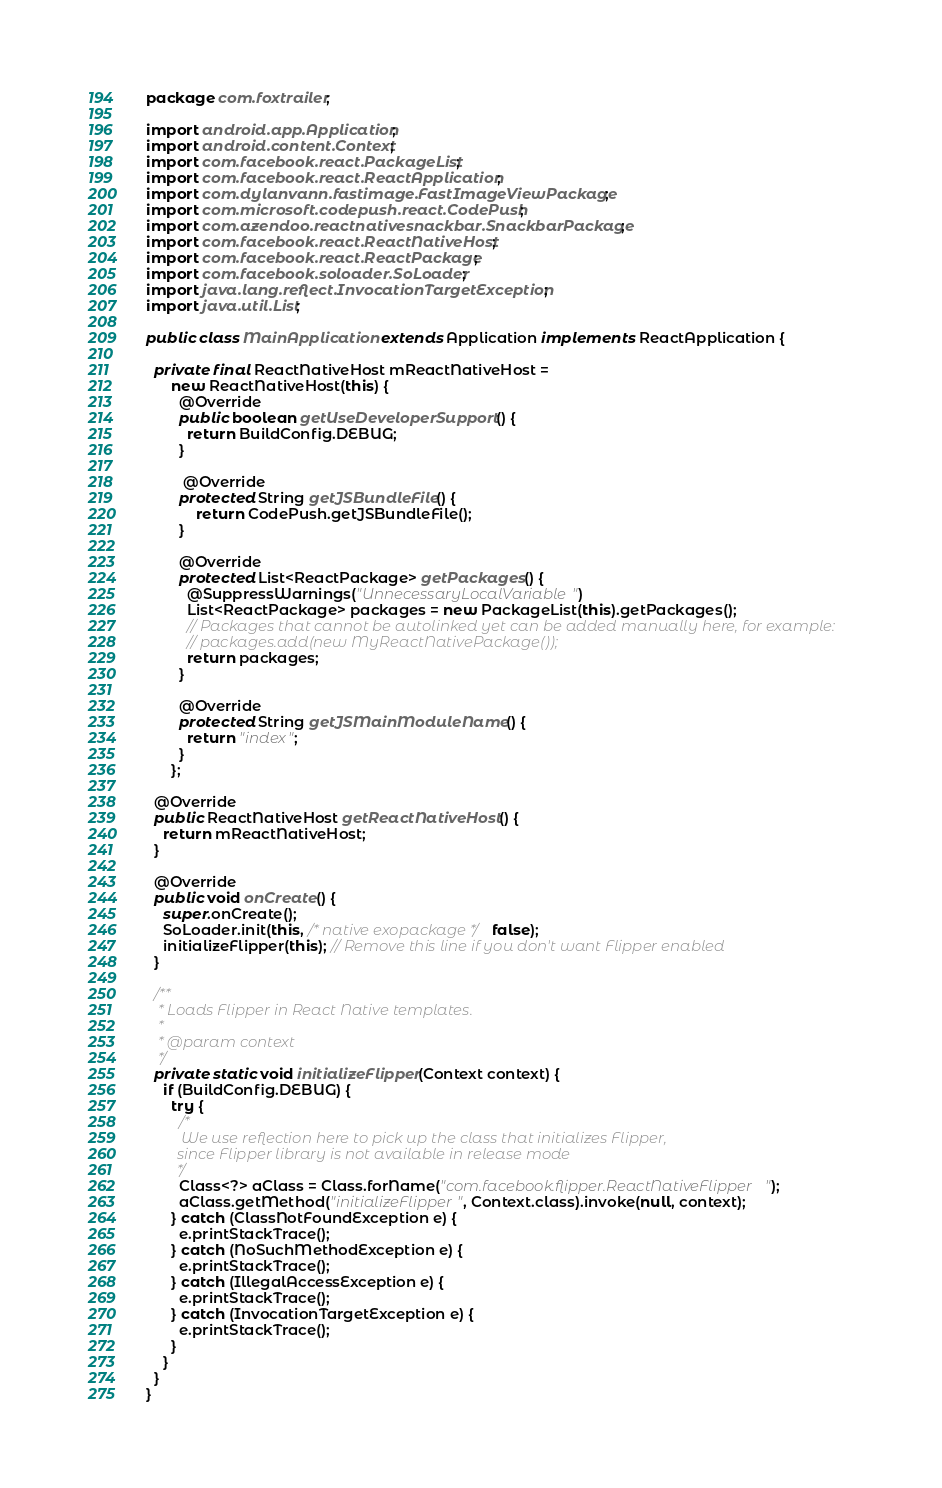<code> <loc_0><loc_0><loc_500><loc_500><_Java_>package com.foxtrailer;

import android.app.Application;
import android.content.Context;
import com.facebook.react.PackageList;
import com.facebook.react.ReactApplication;
import com.dylanvann.fastimage.FastImageViewPackage;
import com.microsoft.codepush.react.CodePush;
import com.azendoo.reactnativesnackbar.SnackbarPackage;
import com.facebook.react.ReactNativeHost;
import com.facebook.react.ReactPackage;
import com.facebook.soloader.SoLoader;
import java.lang.reflect.InvocationTargetException;
import java.util.List;

public class MainApplication extends Application implements ReactApplication {

  private final ReactNativeHost mReactNativeHost =
      new ReactNativeHost(this) {
        @Override
        public boolean getUseDeveloperSupport() {
          return BuildConfig.DEBUG;
        }

         @Override
        protected String getJSBundleFile() {
            return CodePush.getJSBundleFile();
        }

        @Override
        protected List<ReactPackage> getPackages() {
          @SuppressWarnings("UnnecessaryLocalVariable")
          List<ReactPackage> packages = new PackageList(this).getPackages();
          // Packages that cannot be autolinked yet can be added manually here, for example:
          // packages.add(new MyReactNativePackage());
          return packages;
        }

        @Override
        protected String getJSMainModuleName() {
          return "index";
        }
      };

  @Override
  public ReactNativeHost getReactNativeHost() {
    return mReactNativeHost;
  }

  @Override
  public void onCreate() {
    super.onCreate();
    SoLoader.init(this, /* native exopackage */ false);
    initializeFlipper(this); // Remove this line if you don't want Flipper enabled
  }

  /**
   * Loads Flipper in React Native templates.
   *
   * @param context
   */
  private static void initializeFlipper(Context context) {
    if (BuildConfig.DEBUG) {
      try {
        /*
         We use reflection here to pick up the class that initializes Flipper,
        since Flipper library is not available in release mode
        */
        Class<?> aClass = Class.forName("com.facebook.flipper.ReactNativeFlipper");
        aClass.getMethod("initializeFlipper", Context.class).invoke(null, context);
      } catch (ClassNotFoundException e) {
        e.printStackTrace();
      } catch (NoSuchMethodException e) {
        e.printStackTrace();
      } catch (IllegalAccessException e) {
        e.printStackTrace();
      } catch (InvocationTargetException e) {
        e.printStackTrace();
      }
    }
  }
}
</code> 